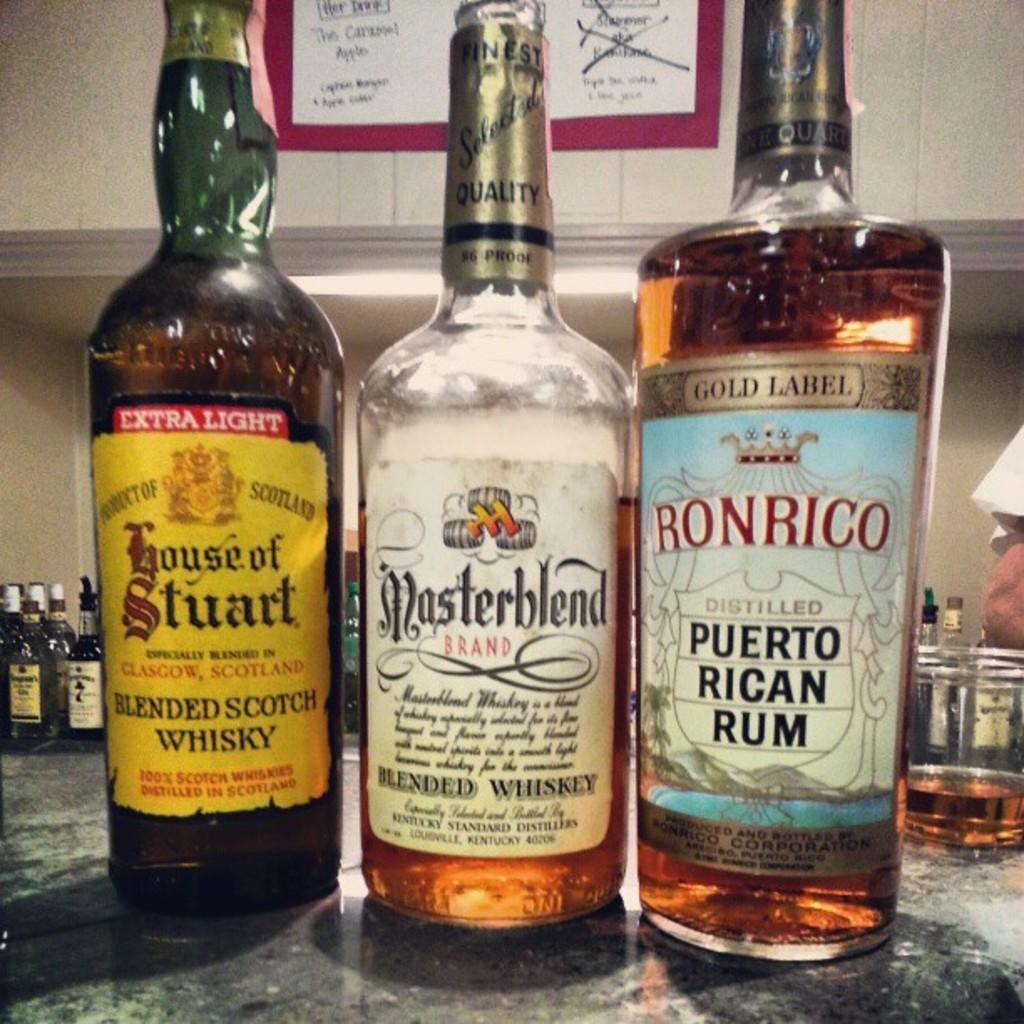<image>
Summarize the visual content of the image. Two different bottles of whiskey are lines up with a bottle of Ronrico Rum. 